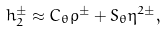<formula> <loc_0><loc_0><loc_500><loc_500>h _ { 2 } ^ { \pm } \approx C _ { \theta } \rho ^ { \pm } + S _ { \theta } \eta ^ { 2 \pm } ,</formula> 